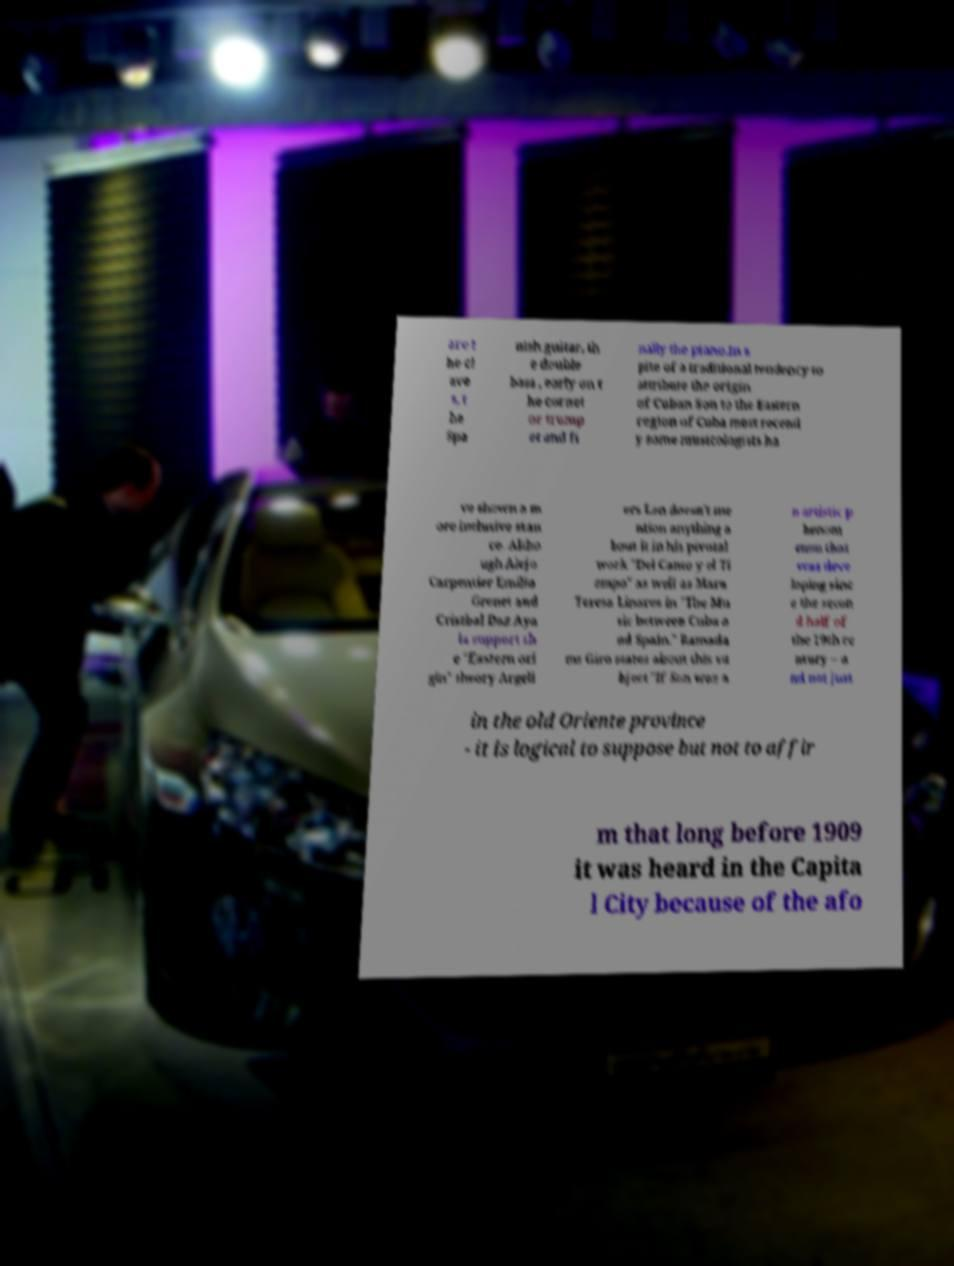Please identify and transcribe the text found in this image. are t he cl ave s, t he Spa nish guitar, th e double bass , early on t he cornet or trump et and fi nally the piano.In s pite of a traditional tendency to attribute the origin of Cuban Son to the Eastern region of Cuba most recentl y some musicologists ha ve shown a m ore inclusive stan ce. Altho ugh Alejo Carpentier Emilio Grenet and Cristbal Daz Aya la support th e "Eastern ori gin" theory Argeli ers Len doesn't me ntion anything a bout it in his pivotal work "Del Canto y el Ti empo" as well as Mara Teresa Linares in "The Mu sic between Cuba a nd Spain." Ramada ms Giro states about this su bject "If Son was a n artistic p henom enon that was deve loping sinc e the secon d half of the 19th ce ntury – a nd not just in the old Oriente province - it is logical to suppose but not to affir m that long before 1909 it was heard in the Capita l City because of the afo 